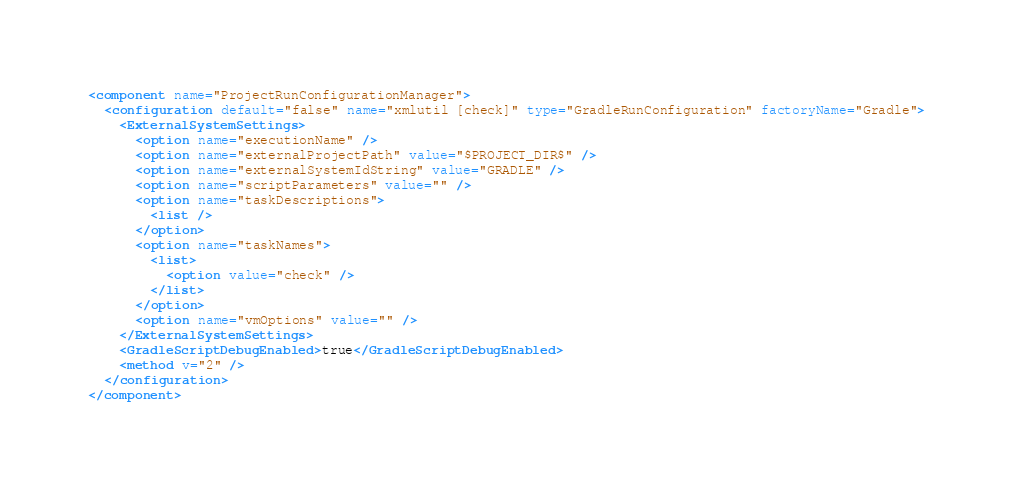Convert code to text. <code><loc_0><loc_0><loc_500><loc_500><_XML_><component name="ProjectRunConfigurationManager">
  <configuration default="false" name="xmlutil [check]" type="GradleRunConfiguration" factoryName="Gradle">
    <ExternalSystemSettings>
      <option name="executionName" />
      <option name="externalProjectPath" value="$PROJECT_DIR$" />
      <option name="externalSystemIdString" value="GRADLE" />
      <option name="scriptParameters" value="" />
      <option name="taskDescriptions">
        <list />
      </option>
      <option name="taskNames">
        <list>
          <option value="check" />
        </list>
      </option>
      <option name="vmOptions" value="" />
    </ExternalSystemSettings>
    <GradleScriptDebugEnabled>true</GradleScriptDebugEnabled>
    <method v="2" />
  </configuration>
</component></code> 